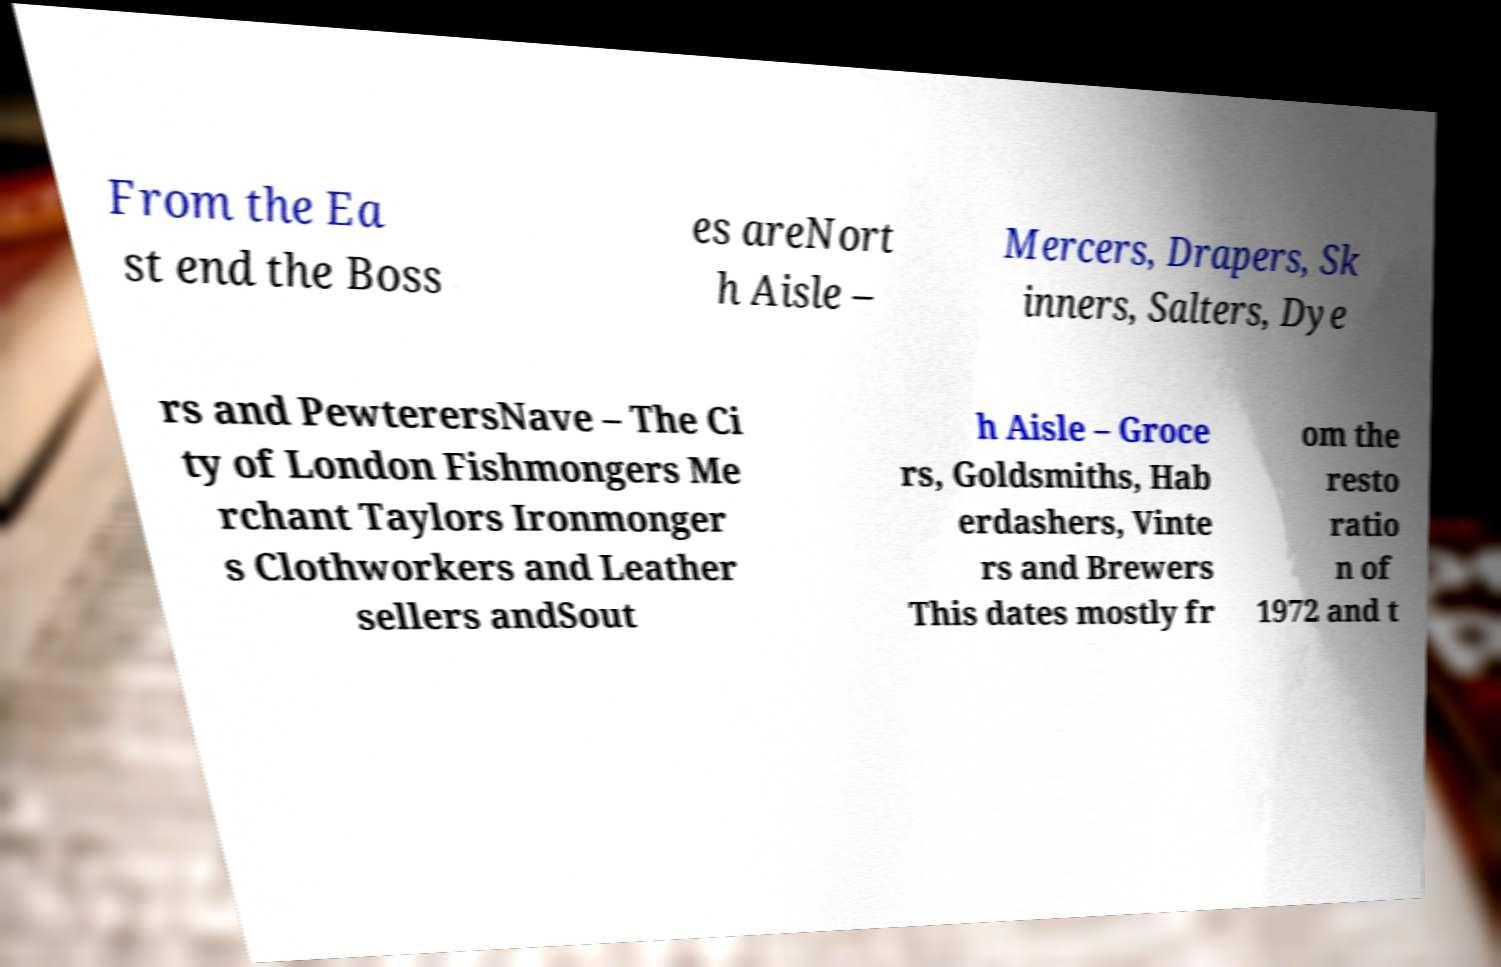There's text embedded in this image that I need extracted. Can you transcribe it verbatim? From the Ea st end the Boss es areNort h Aisle – Mercers, Drapers, Sk inners, Salters, Dye rs and PewterersNave – The Ci ty of London Fishmongers Me rchant Taylors Ironmonger s Clothworkers and Leather sellers andSout h Aisle – Groce rs, Goldsmiths, Hab erdashers, Vinte rs and Brewers This dates mostly fr om the resto ratio n of 1972 and t 